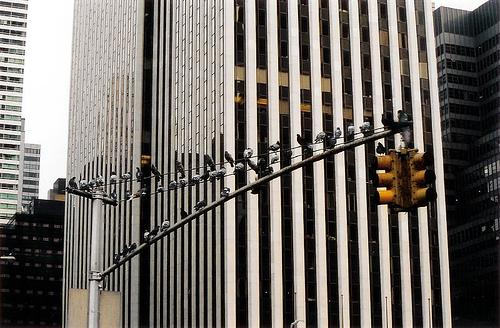What are the birds perched on?

Choices:
A) bench
B) traffic light
C) branch
D) window traffic light 